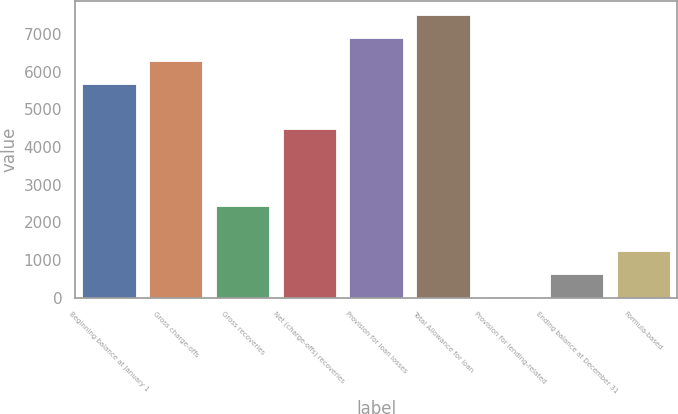Convert chart to OTSL. <chart><loc_0><loc_0><loc_500><loc_500><bar_chart><fcel>Beginning balance at January 1<fcel>Gross charge-offs<fcel>Gross recoveries<fcel>Net (charge-offs) recoveries<fcel>Provision for loan losses<fcel>Total Allowance for loan<fcel>Provision for lending-related<fcel>Ending balance at December 31<fcel>Formula-based<nl><fcel>5683<fcel>6291.5<fcel>2444<fcel>4466<fcel>6900<fcel>7508.5<fcel>10<fcel>618.5<fcel>1227<nl></chart> 